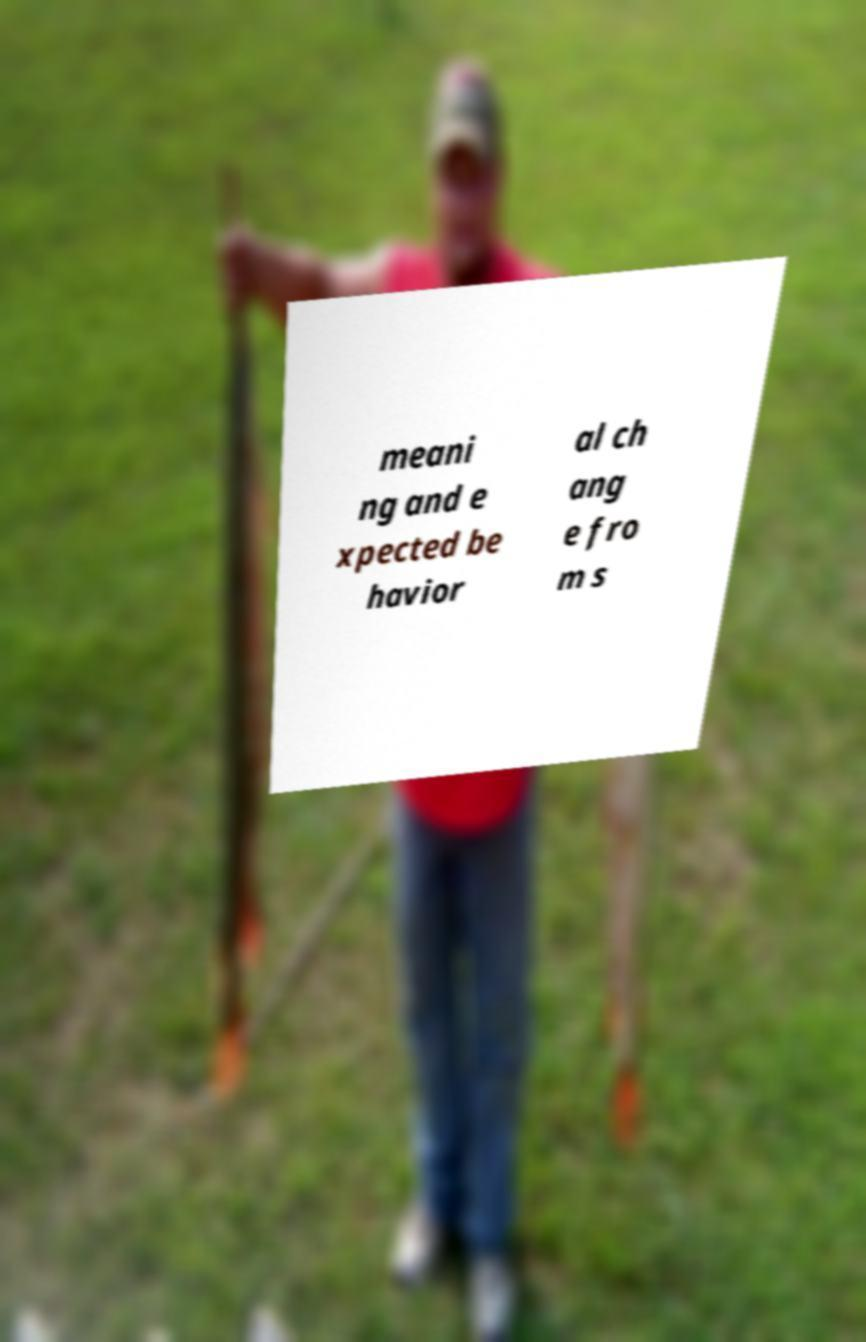Please read and relay the text visible in this image. What does it say? meani ng and e xpected be havior al ch ang e fro m s 